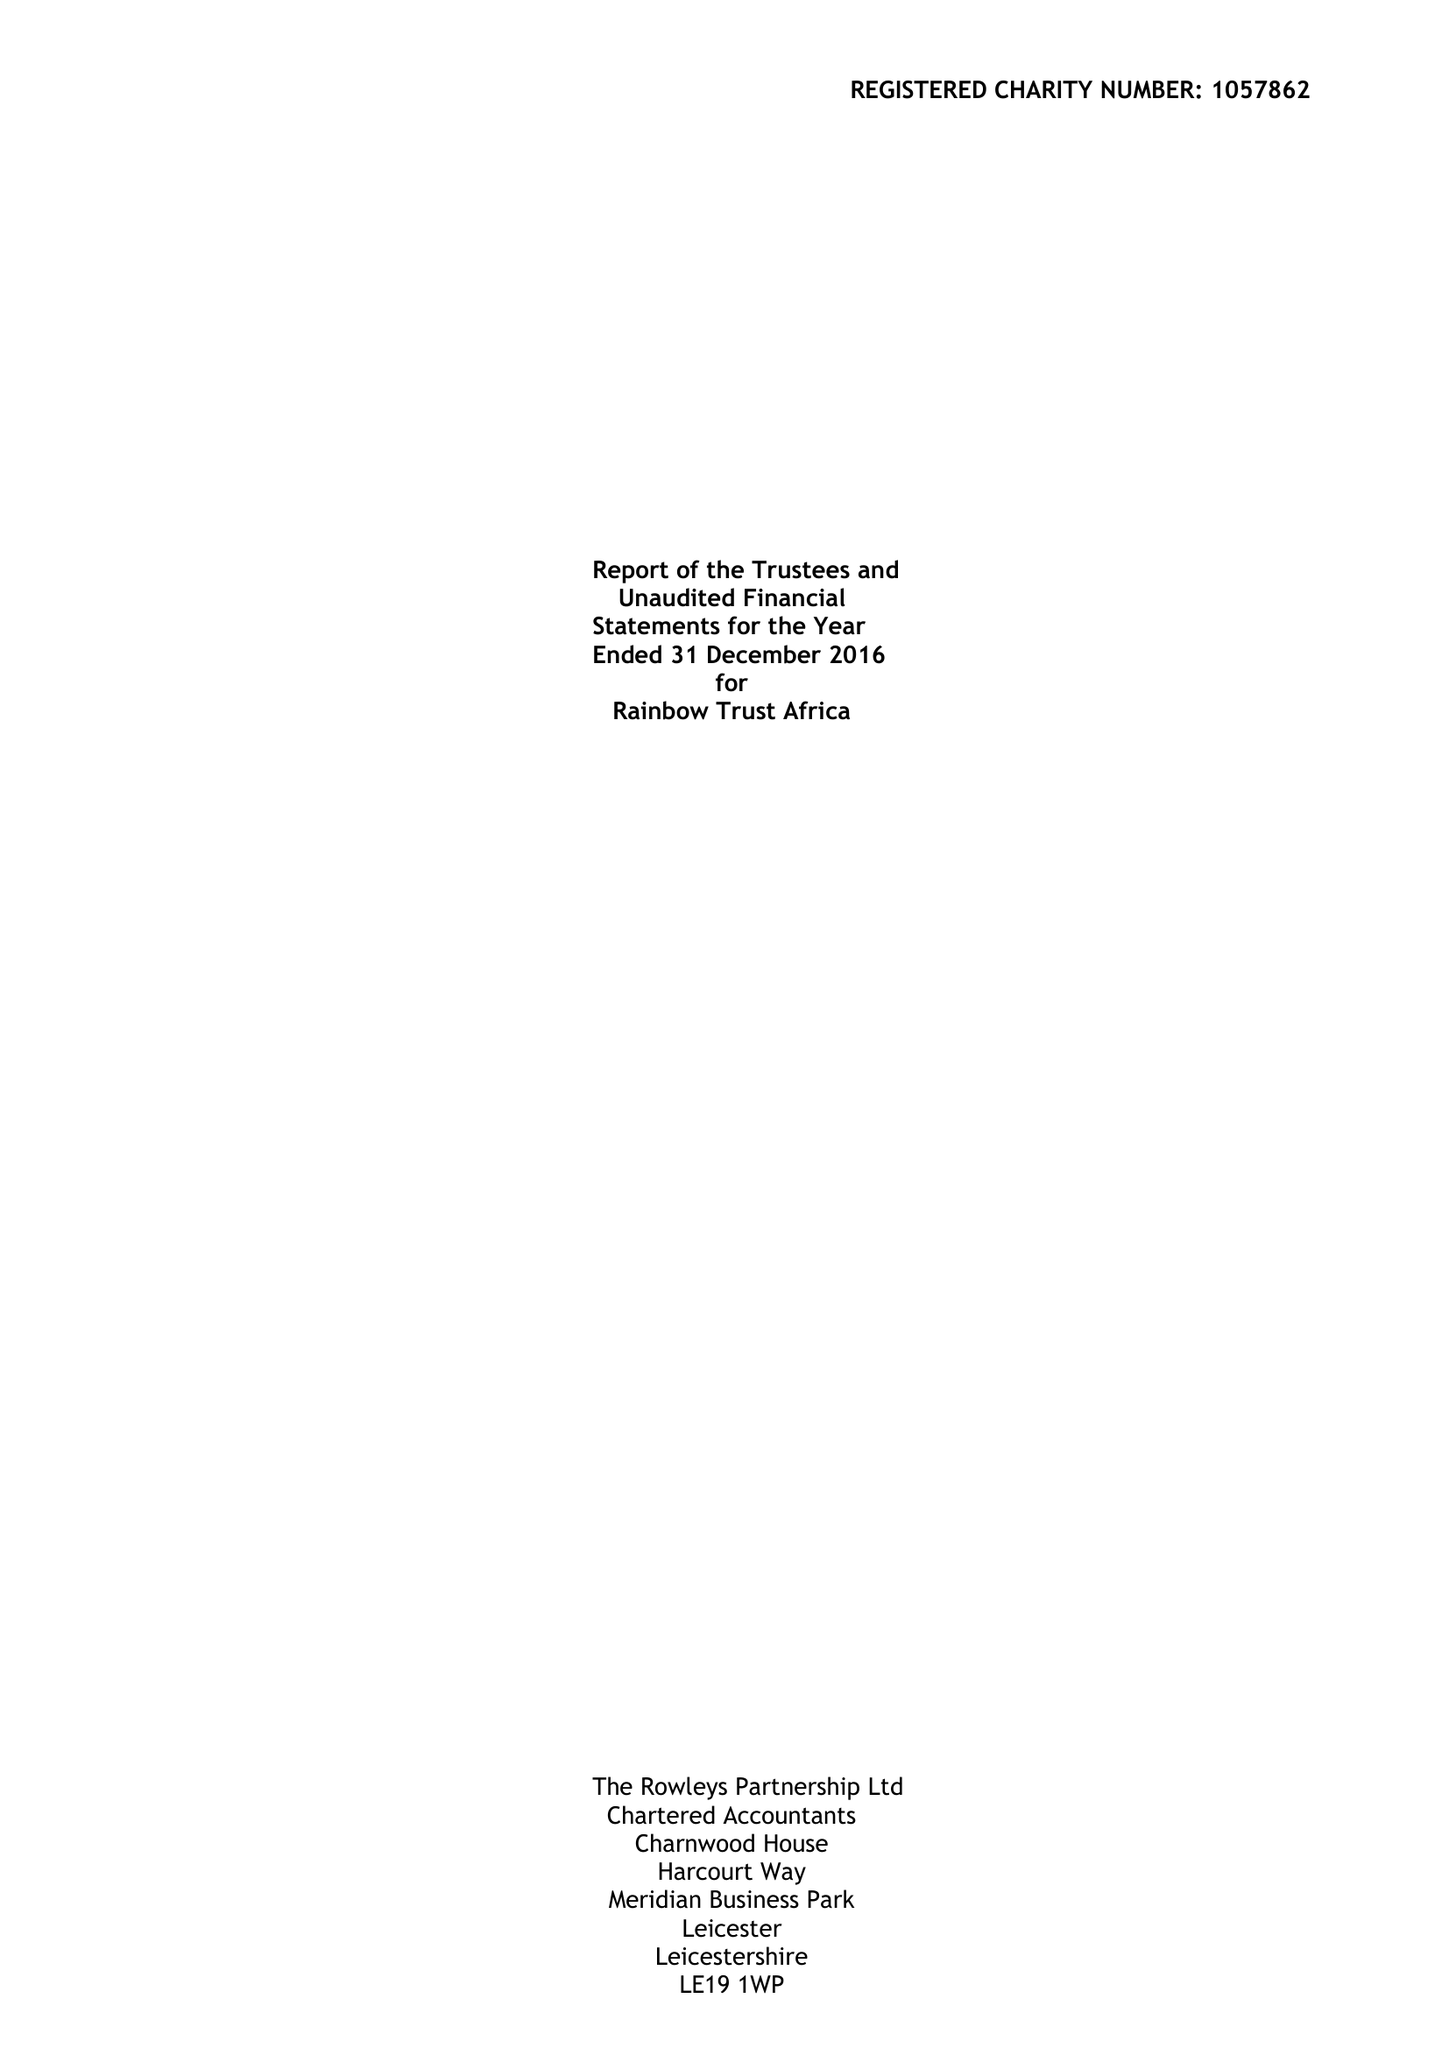What is the value for the address__street_line?
Answer the question using a single word or phrase. 22 DE MONTFORT STREET 